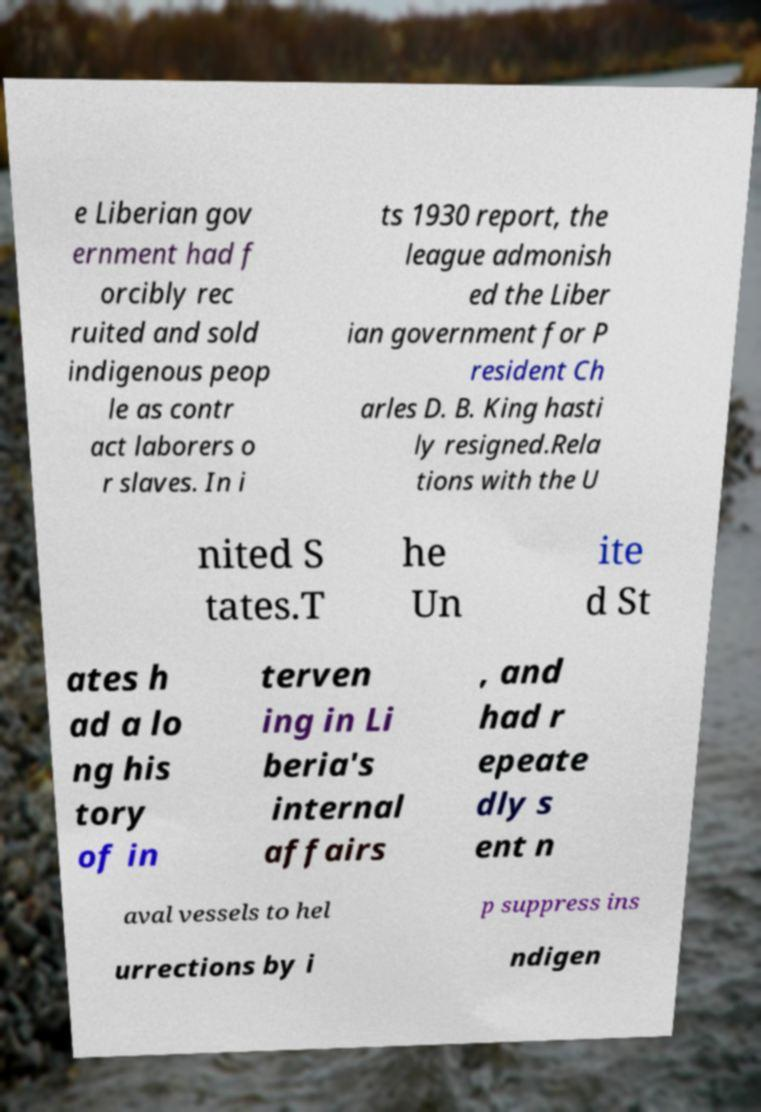Please identify and transcribe the text found in this image. e Liberian gov ernment had f orcibly rec ruited and sold indigenous peop le as contr act laborers o r slaves. In i ts 1930 report, the league admonish ed the Liber ian government for P resident Ch arles D. B. King hasti ly resigned.Rela tions with the U nited S tates.T he Un ite d St ates h ad a lo ng his tory of in terven ing in Li beria's internal affairs , and had r epeate dly s ent n aval vessels to hel p suppress ins urrections by i ndigen 